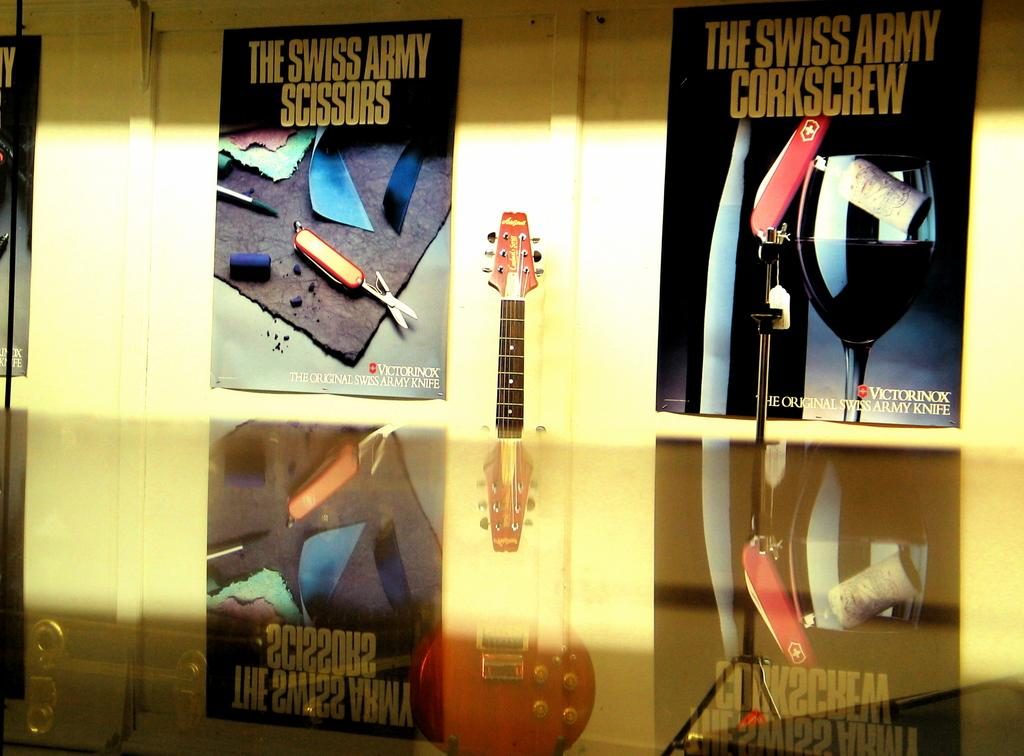<image>
Provide a brief description of the given image. A collection of pictures with Swiss army items. 